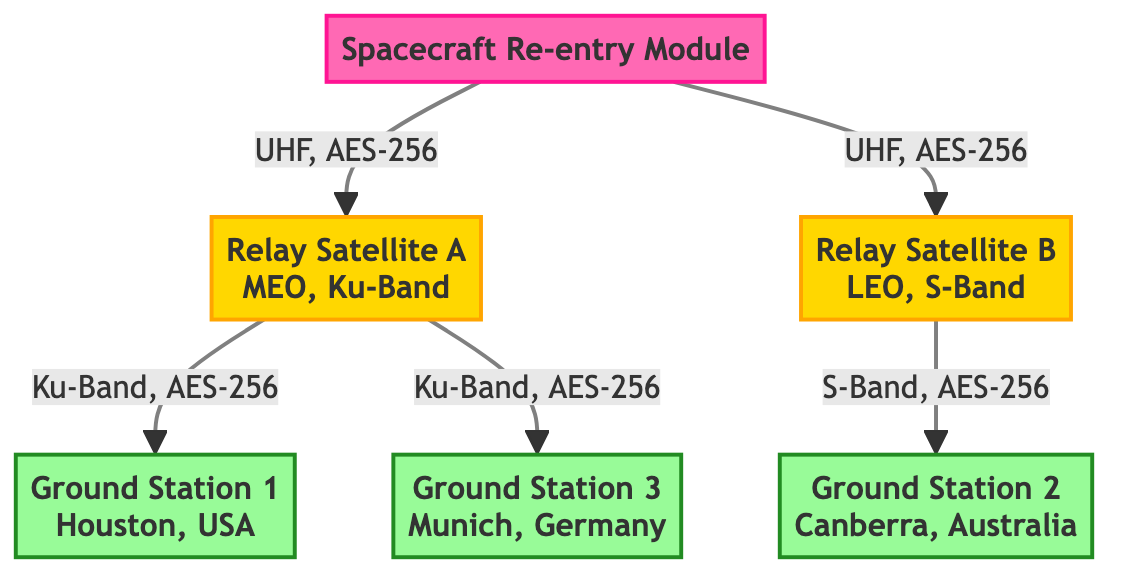What type of satellite is Relay Satellite A? The diagram states Relay Satellite A is classified as a MEO (Medium Earth Orbit) satellite.
Answer: MEO How many ground stations are shown in the diagram? By counting the listed ground stations, there are a total of three: Ground Station 1, Ground Station 2, and Ground Station 3.
Answer: 3 What frequency band is used for communication between the Spacecraft Re-entry Module and Relay Satellite A? The diagram indicates that the frequency band for the link from the Spacecraft Re-entry Module to Relay Satellite A is UHF.
Answer: UHF Which ground station receives data from Relay Satellite B? From the diagram, Relay Satellite B has a downlink communication link to Ground Station 2, which is located in Canberra, Australia.
Answer: Ground Station 2 What type of encryption is used for the communication links? The diagram specifies that AES-256 is the encryption standard used for all the communication links shown.
Answer: AES-256 How many direct links are there from the Spacecraft Re-entry Module? The diagram shows that there are two direct links originating from the Spacecraft Re-entry Module, one to Relay Satellite A and one to Relay Satellite B.
Answer: 2 What is the position of Relay Satellite A? The diagram denotes that Relay Satellite A is positioned at 120°E longitude.
Answer: 120°E Which frequency band is used by Ground Station 3? According to the diagram, Ground Station 3 in Munich, Germany, operates on the X-Band frequency.
Answer: X-Band What is the shielding used for the Spacecraft Re-entry Module? The diagram indicates that the Spacecraft Re-entry Module utilizes a Thermal Protection System as its shielding during re-entry.
Answer: Thermal Protection System 